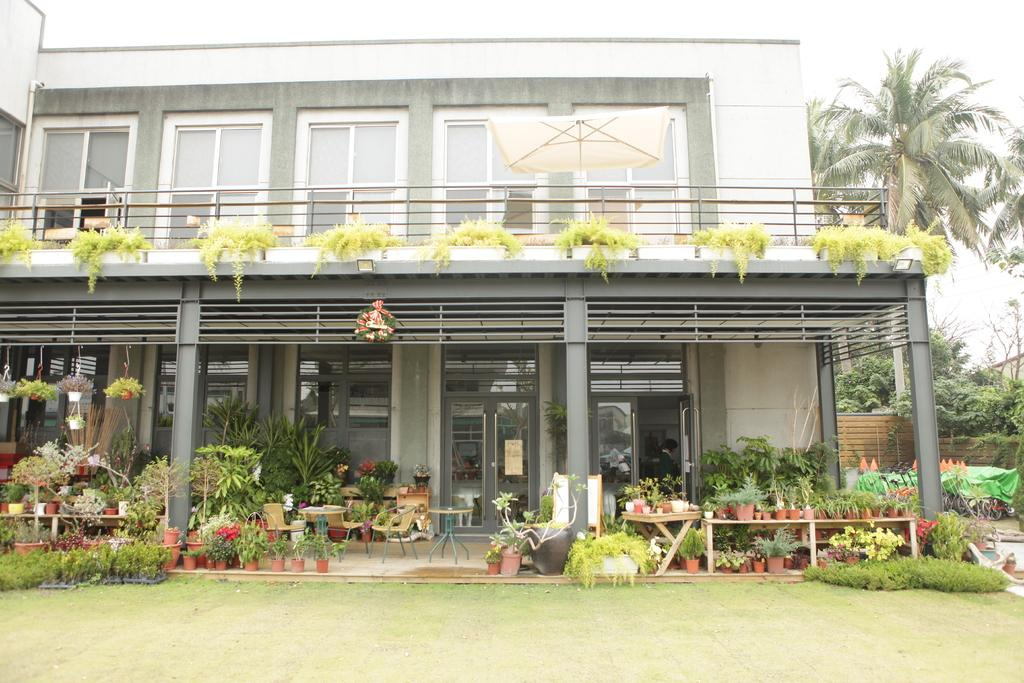What type of structure is visible in the image? There is a building in the image. What can be seen in the background of the image? There are trees in the image. What type of furniture is present in the image? There are tables and chairs in the image. What type of greenery is visible in the image? There are house plants in the image. How many chickens are sitting on the bed in the image? There are no chickens or beds present in the image. 